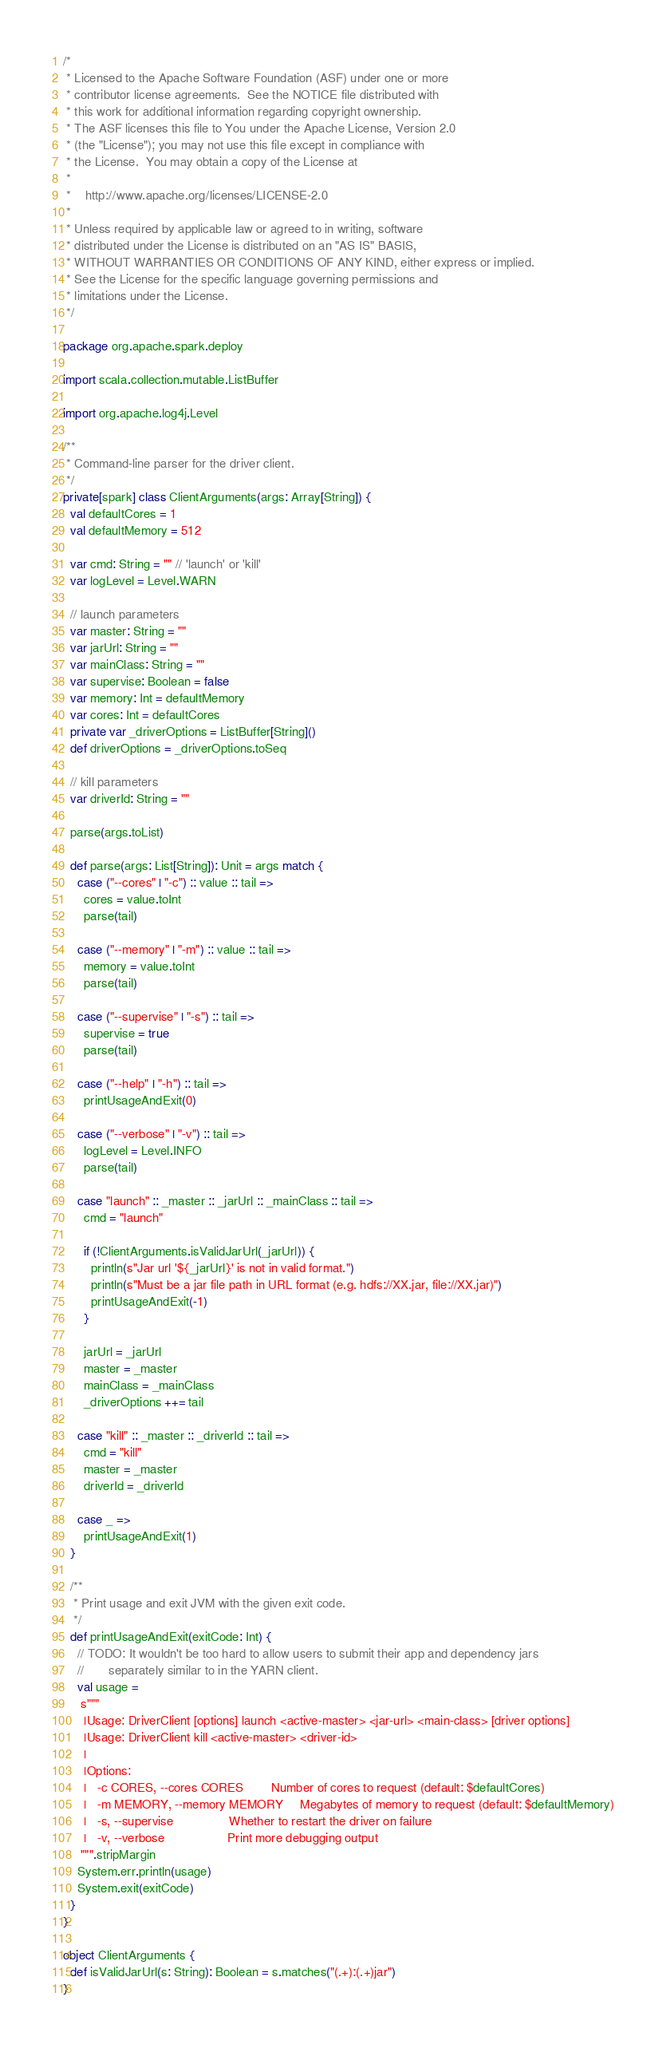<code> <loc_0><loc_0><loc_500><loc_500><_Scala_>/*
 * Licensed to the Apache Software Foundation (ASF) under one or more
 * contributor license agreements.  See the NOTICE file distributed with
 * this work for additional information regarding copyright ownership.
 * The ASF licenses this file to You under the Apache License, Version 2.0
 * (the "License"); you may not use this file except in compliance with
 * the License.  You may obtain a copy of the License at
 *
 *    http://www.apache.org/licenses/LICENSE-2.0
 *
 * Unless required by applicable law or agreed to in writing, software
 * distributed under the License is distributed on an "AS IS" BASIS,
 * WITHOUT WARRANTIES OR CONDITIONS OF ANY KIND, either express or implied.
 * See the License for the specific language governing permissions and
 * limitations under the License.
 */

package org.apache.spark.deploy

import scala.collection.mutable.ListBuffer

import org.apache.log4j.Level

/**
 * Command-line parser for the driver client.
 */
private[spark] class ClientArguments(args: Array[String]) {
  val defaultCores = 1
  val defaultMemory = 512

  var cmd: String = "" // 'launch' or 'kill'
  var logLevel = Level.WARN

  // launch parameters
  var master: String = ""
  var jarUrl: String = ""
  var mainClass: String = ""
  var supervise: Boolean = false
  var memory: Int = defaultMemory
  var cores: Int = defaultCores
  private var _driverOptions = ListBuffer[String]()
  def driverOptions = _driverOptions.toSeq

  // kill parameters
  var driverId: String = ""

  parse(args.toList)

  def parse(args: List[String]): Unit = args match {
    case ("--cores" | "-c") :: value :: tail =>
      cores = value.toInt
      parse(tail)

    case ("--memory" | "-m") :: value :: tail =>
      memory = value.toInt
      parse(tail)

    case ("--supervise" | "-s") :: tail =>
      supervise = true
      parse(tail)

    case ("--help" | "-h") :: tail =>
      printUsageAndExit(0)

    case ("--verbose" | "-v") :: tail =>
      logLevel = Level.INFO
      parse(tail)

    case "launch" :: _master :: _jarUrl :: _mainClass :: tail =>
      cmd = "launch"

      if (!ClientArguments.isValidJarUrl(_jarUrl)) {
        println(s"Jar url '${_jarUrl}' is not in valid format.")
        println(s"Must be a jar file path in URL format (e.g. hdfs://XX.jar, file://XX.jar)")
        printUsageAndExit(-1)
      }

      jarUrl = _jarUrl
      master = _master
      mainClass = _mainClass
      _driverOptions ++= tail

    case "kill" :: _master :: _driverId :: tail =>
      cmd = "kill"
      master = _master
      driverId = _driverId

    case _ =>
      printUsageAndExit(1)
  }

  /**
   * Print usage and exit JVM with the given exit code.
   */
  def printUsageAndExit(exitCode: Int) {
    // TODO: It wouldn't be too hard to allow users to submit their app and dependency jars
    //       separately similar to in the YARN client.
    val usage =
     s"""
      |Usage: DriverClient [options] launch <active-master> <jar-url> <main-class> [driver options]
      |Usage: DriverClient kill <active-master> <driver-id>
      |
      |Options:
      |   -c CORES, --cores CORES        Number of cores to request (default: $defaultCores)
      |   -m MEMORY, --memory MEMORY     Megabytes of memory to request (default: $defaultMemory)
      |   -s, --supervise                Whether to restart the driver on failure
      |   -v, --verbose                  Print more debugging output
     """.stripMargin
    System.err.println(usage)
    System.exit(exitCode)
  }
}

object ClientArguments {
  def isValidJarUrl(s: String): Boolean = s.matches("(.+):(.+)jar")
}
</code> 